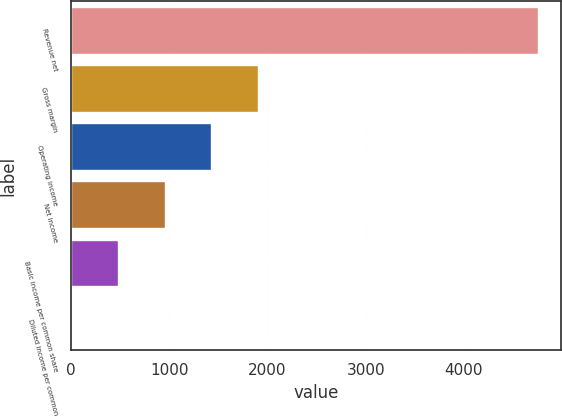Convert chart. <chart><loc_0><loc_0><loc_500><loc_500><bar_chart><fcel>Revenue net<fcel>Gross margin<fcel>Operating income<fcel>Net income<fcel>Basic income per common share<fcel>Diluted income per common<nl><fcel>4754<fcel>1903.31<fcel>1428.2<fcel>953.09<fcel>477.98<fcel>2.87<nl></chart> 